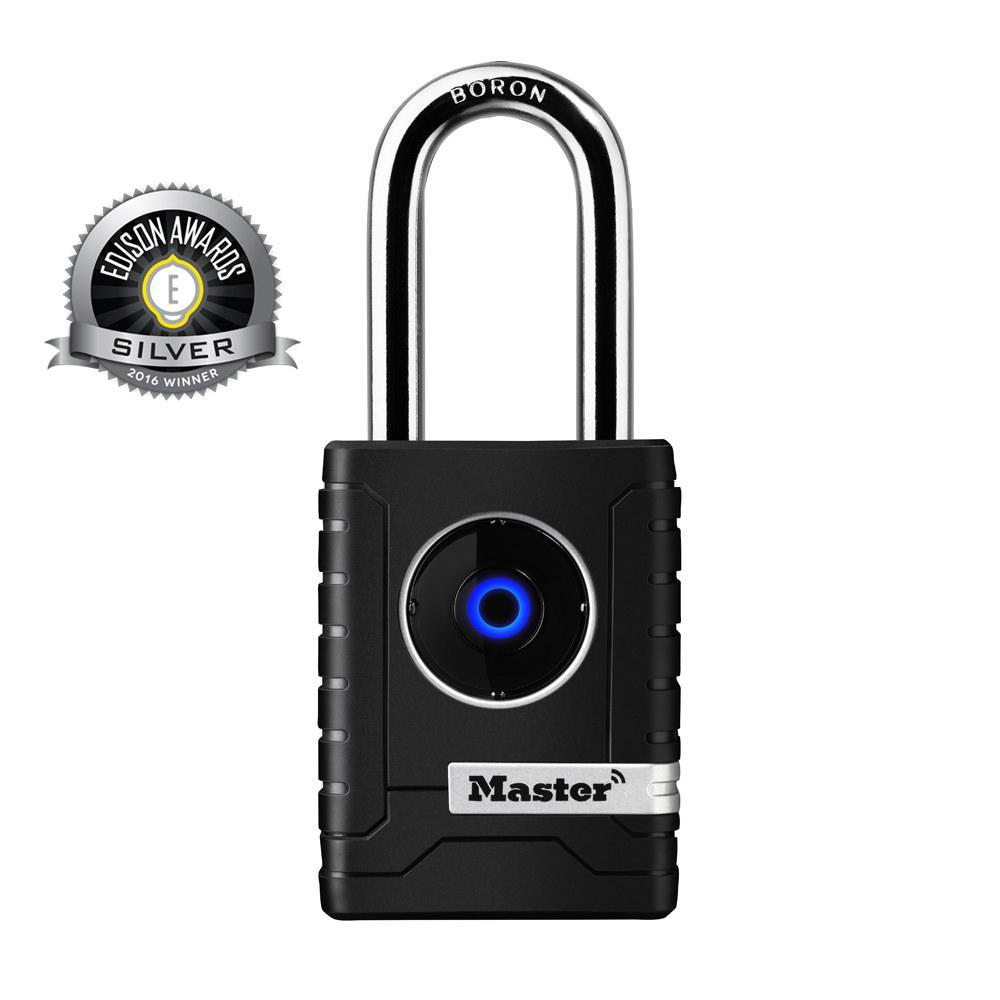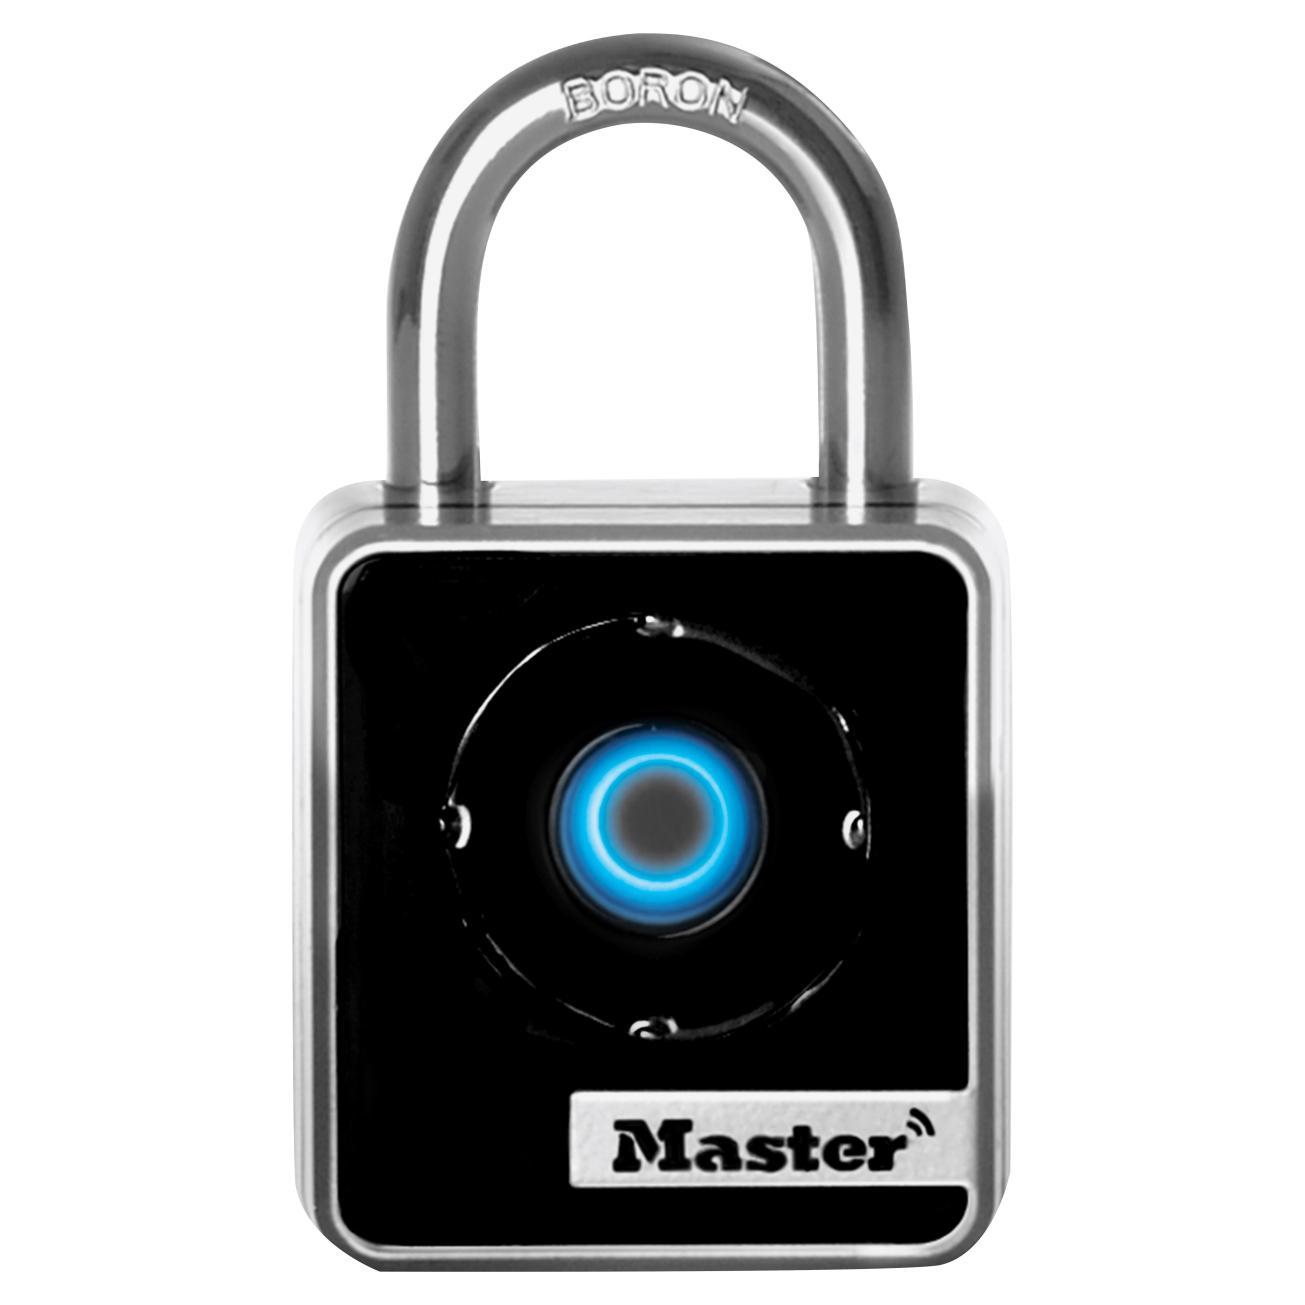The first image is the image on the left, the second image is the image on the right. Considering the images on both sides, is "At least one image is a manual mechanical combination lock with a logo design other than a blue circle." valid? Answer yes or no. No. The first image is the image on the left, the second image is the image on the right. Analyze the images presented: Is the assertion "One lock features a red diamond shape on the front of a lock near three vertical combination wheels." valid? Answer yes or no. No. The first image is the image on the left, the second image is the image on the right. For the images displayed, is the sentence "There is a numbered padlock in one of the images." factually correct? Answer yes or no. No. The first image is the image on the left, the second image is the image on the right. For the images shown, is this caption "An image shows a lock with three rows of numbers to enter the combination." true? Answer yes or no. No. 